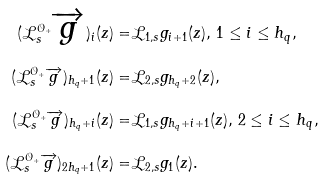Convert formula to latex. <formula><loc_0><loc_0><loc_500><loc_500>( \mathcal { L } _ { s } ^ { { \mathcal { O } _ { + } } } \overrightarrow { g } ) _ { i } ( z ) = & \mathcal { L } _ { 1 , s } g _ { i + 1 } ( z ) , \, 1 \leq i \leq h _ { q } , \\ ( \mathcal { L } _ { s } ^ { { \mathcal { O } _ { + } } } \overrightarrow { g } ) _ { h _ { q } + 1 } ( z ) = & \mathcal { L } _ { 2 , s } g _ { h _ { q } + 2 } ( z ) , \\ ( \mathcal { L } _ { s } ^ { { \mathcal { O } _ { + } } } \overrightarrow { g } ) _ { h _ { q } + i } ( z ) = & \mathcal { L } _ { 1 , s } g _ { h _ { q } + i + 1 } ( z ) , \, 2 \leq i \leq h _ { q } , \\ ( \mathcal { L } _ { s } ^ { { \mathcal { O } _ { + } } } \overrightarrow { g } ) _ { 2 h _ { q } + 1 } ( z ) = & \mathcal { L } _ { 2 , s } g _ { 1 } ( z ) .</formula> 